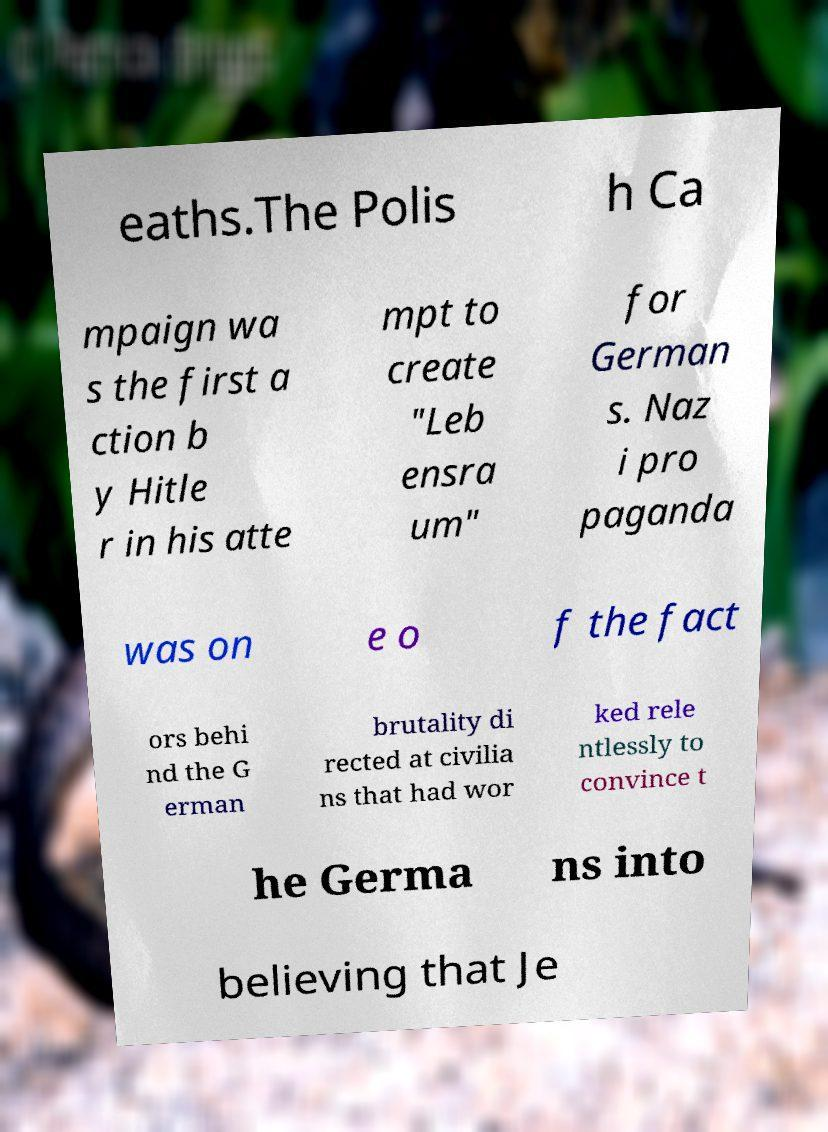Please identify and transcribe the text found in this image. eaths.The Polis h Ca mpaign wa s the first a ction b y Hitle r in his atte mpt to create "Leb ensra um" for German s. Naz i pro paganda was on e o f the fact ors behi nd the G erman brutality di rected at civilia ns that had wor ked rele ntlessly to convince t he Germa ns into believing that Je 